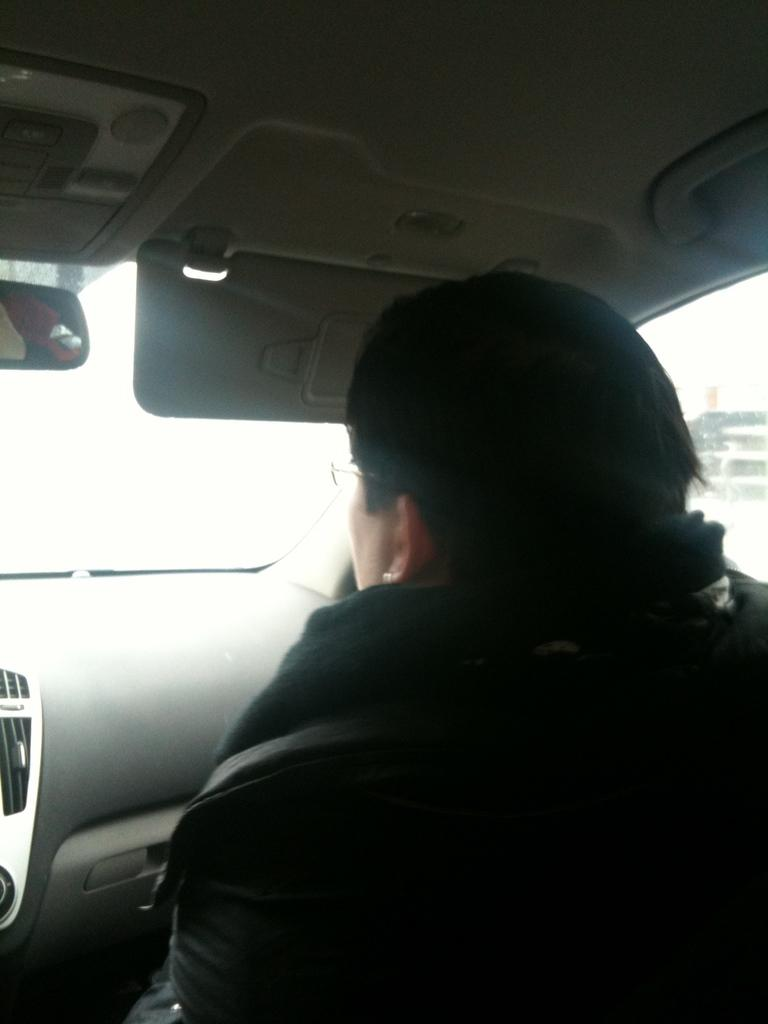What is happening in the image? There is a person in the image, and they are driving a car. Can you describe the person's activity in the image? The person is driving a car, which means they are operating the vehicle and navigating the road. What type of stream can be seen flowing through the car in the image? There is no stream present in the image; it features a person driving a car. What things are visible in the air during the person's flight in the image? The image does not depict a flight or any objects in the air. 